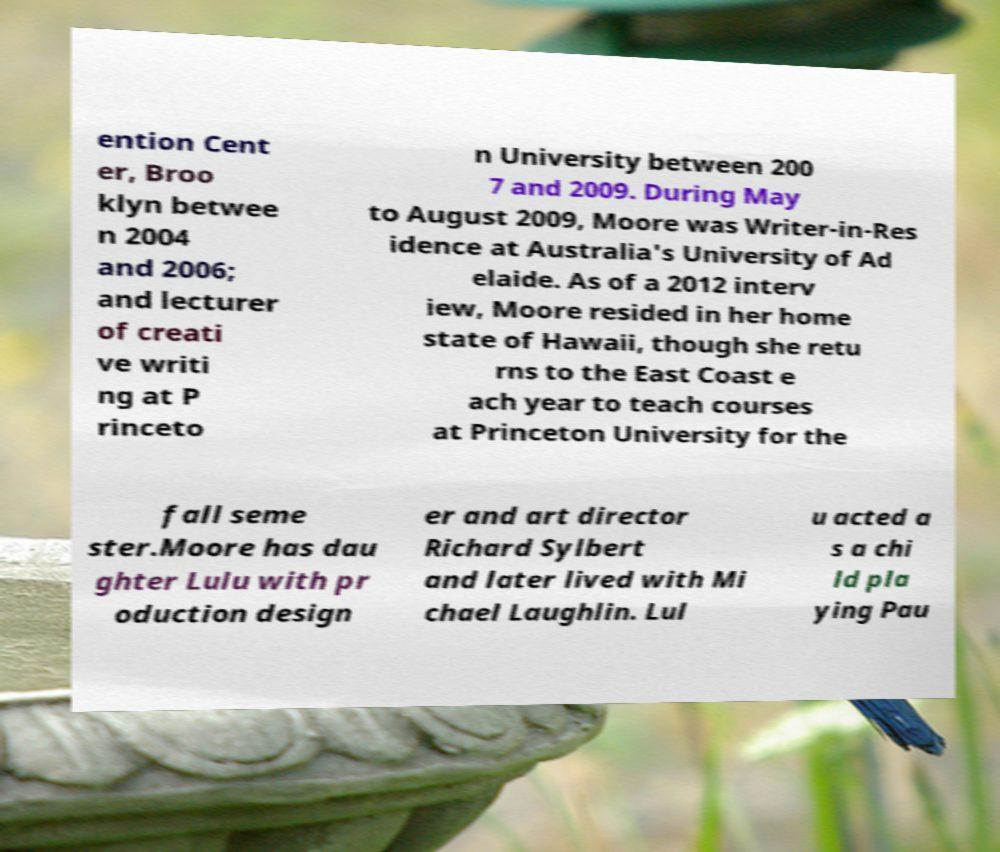Can you read and provide the text displayed in the image?This photo seems to have some interesting text. Can you extract and type it out for me? ention Cent er, Broo klyn betwee n 2004 and 2006; and lecturer of creati ve writi ng at P rinceto n University between 200 7 and 2009. During May to August 2009, Moore was Writer-in-Res idence at Australia's University of Ad elaide. As of a 2012 interv iew, Moore resided in her home state of Hawaii, though she retu rns to the East Coast e ach year to teach courses at Princeton University for the fall seme ster.Moore has dau ghter Lulu with pr oduction design er and art director Richard Sylbert and later lived with Mi chael Laughlin. Lul u acted a s a chi ld pla ying Pau 